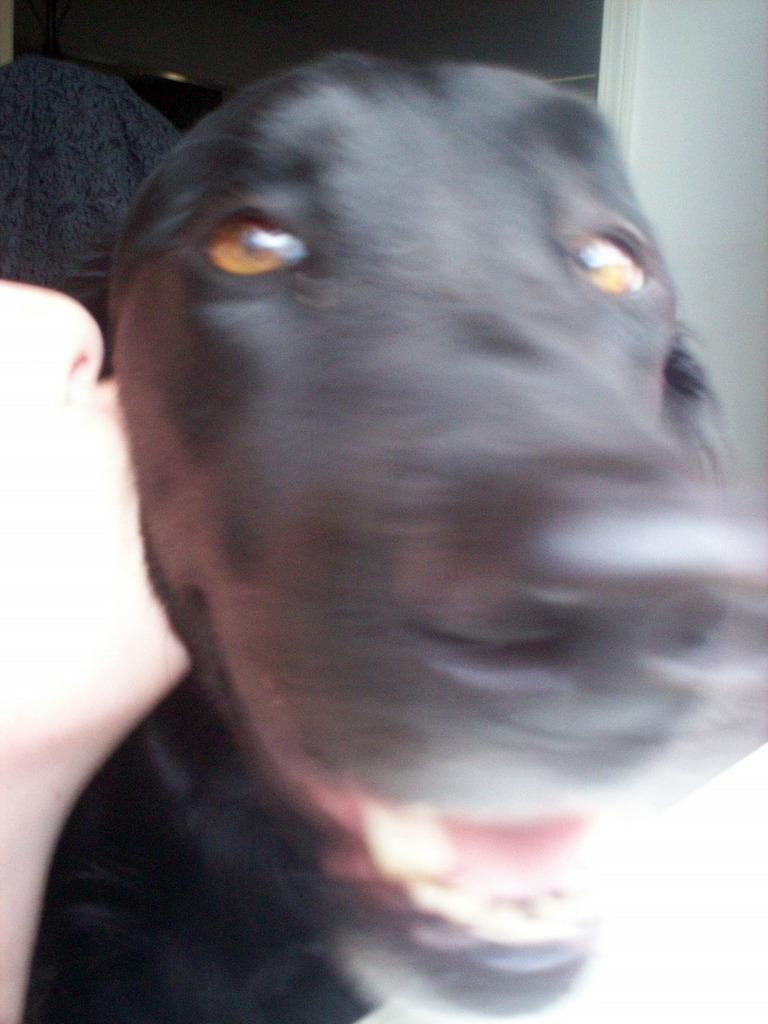Who is present on the left side of the image? There is a person on the left side of the image. What is the person doing in the image? The person is kissing a black dog. How does the black dog appear in the image? The black dog has its mouth open. What can be seen in the background of the image? There is a white wall in the background of the image. What type of soap is being used to clean the dog's wing in the image? There is no soap, dog's wing, or cleaning activity present in the image. 